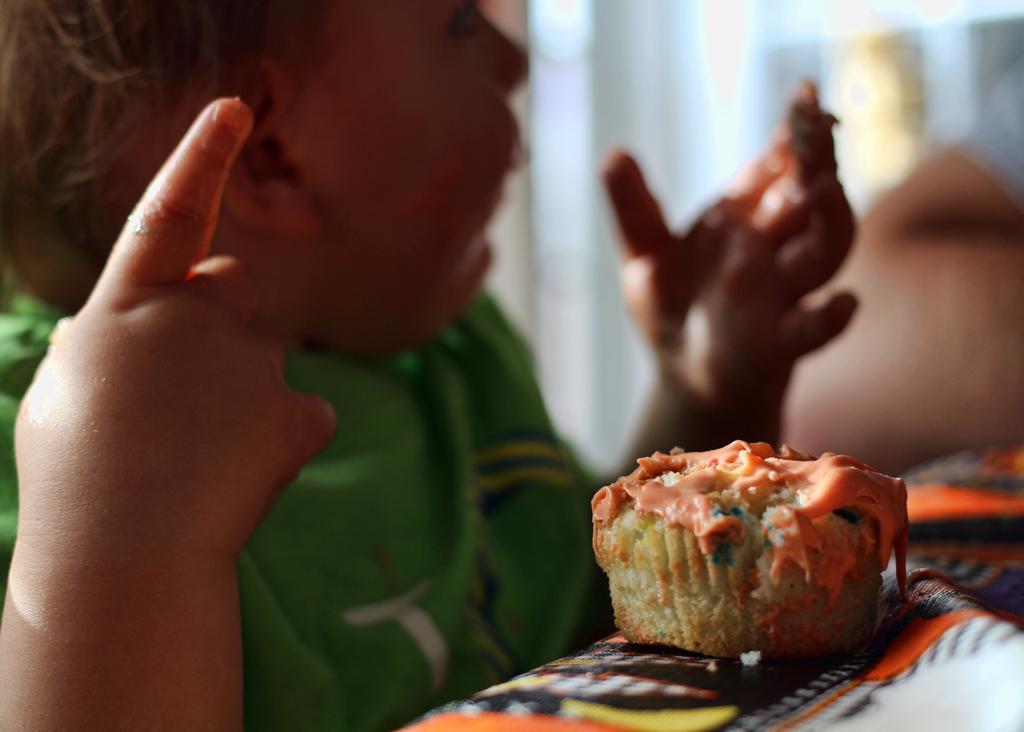Can you describe this image briefly? In this picture there is a baby girl who is wearing green jacket. In-front of her I can see the cake which is kept on the table. In the back I can see the blur image. 